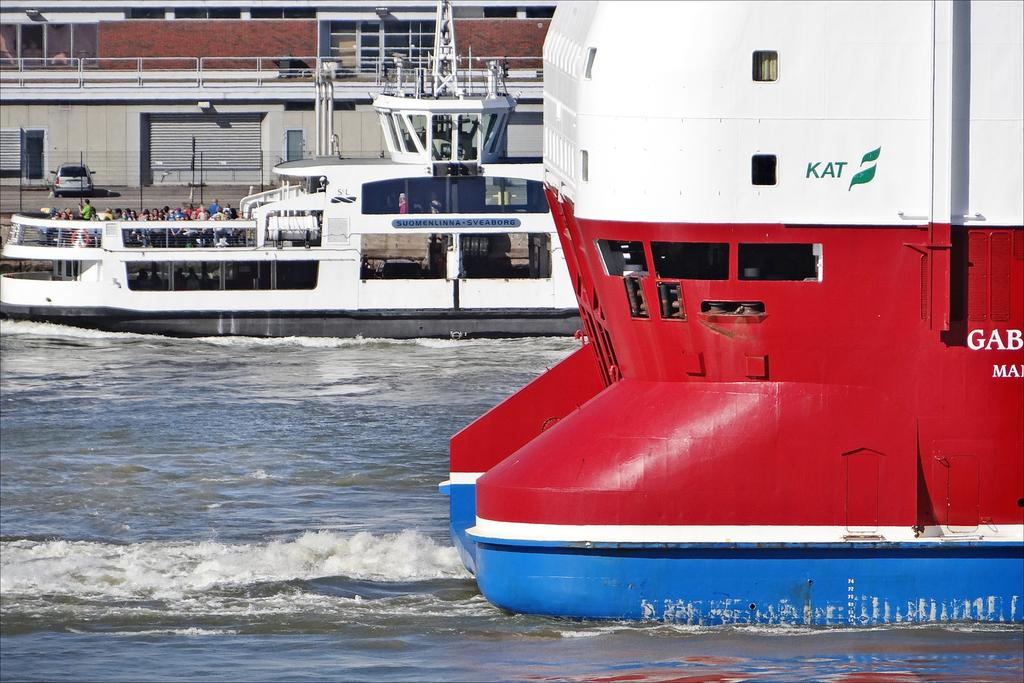Provide a one-sentence caption for the provided image. A large blue, red and white boat that is passing by has KAT and a green flag on the side of it. 